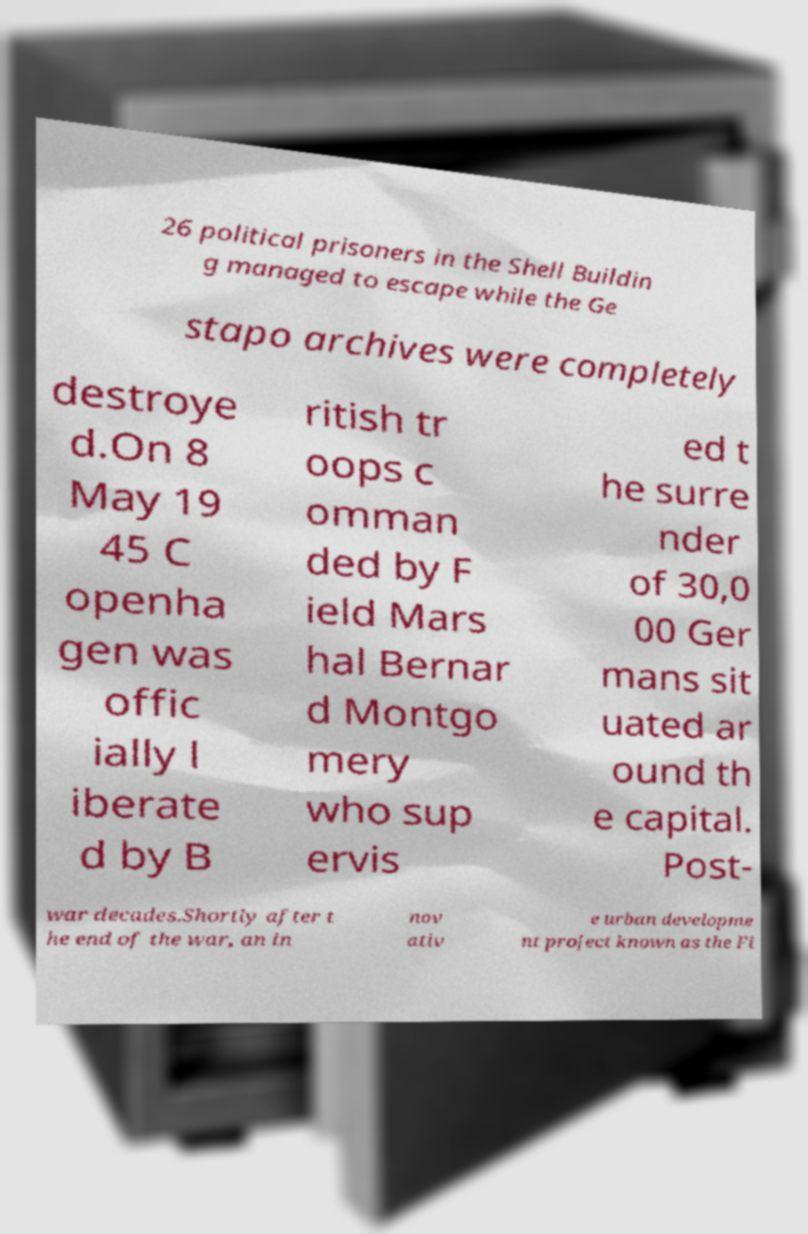Could you extract and type out the text from this image? 26 political prisoners in the Shell Buildin g managed to escape while the Ge stapo archives were completely destroye d.On 8 May 19 45 C openha gen was offic ially l iberate d by B ritish tr oops c omman ded by F ield Mars hal Bernar d Montgo mery who sup ervis ed t he surre nder of 30,0 00 Ger mans sit uated ar ound th e capital. Post- war decades.Shortly after t he end of the war, an in nov ativ e urban developme nt project known as the Fi 